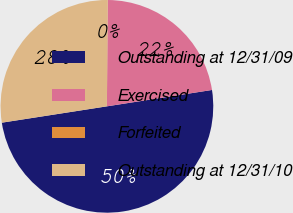Convert chart. <chart><loc_0><loc_0><loc_500><loc_500><pie_chart><fcel>Outstanding at 12/31/09<fcel>Exercised<fcel>Forfeited<fcel>Outstanding at 12/31/10<nl><fcel>50.0%<fcel>22.4%<fcel>0.05%<fcel>27.54%<nl></chart> 